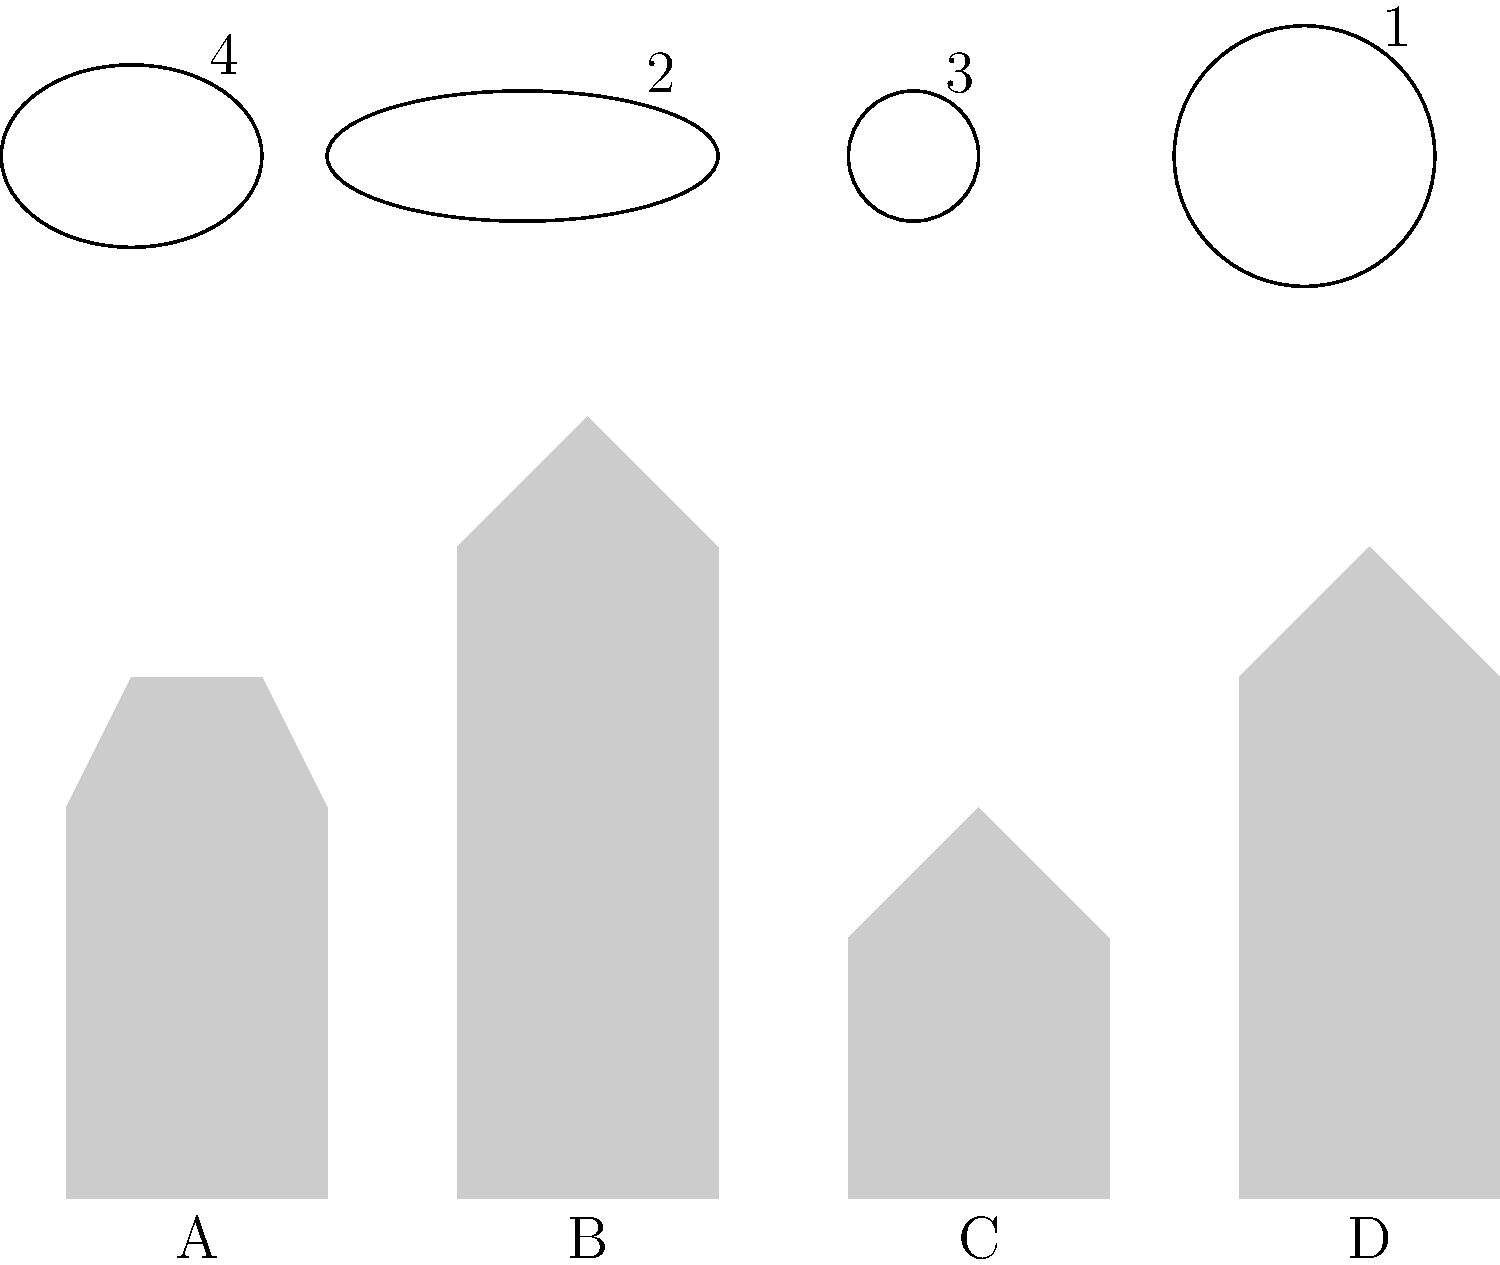Match the dog breed silhouettes (A, B, C, D) with their corresponding head shapes (1, 2, 3, 4). Which number matches with silhouette C? Let's analyze each silhouette and shape:

1. Silhouette A: Short and stocky body, likely a Beagle. Its head shape would be slightly elongated, matching shape 4.

2. Silhouette B: Tall with pointed ears, characteristic of a German Shepherd. Its head shape would be more elongated, matching shape 2.

3. Silhouette C: Long body and short legs, typical of a Dachshund. Its head shape would be the smallest and roundest, matching shape 3.

4. Silhouette D: Medium-sized with a balanced body, likely a Labrador. Its head shape would be the largest and roundest, matching shape 1.

Therefore, silhouette C (Dachshund) matches with head shape 3.
Answer: 3 